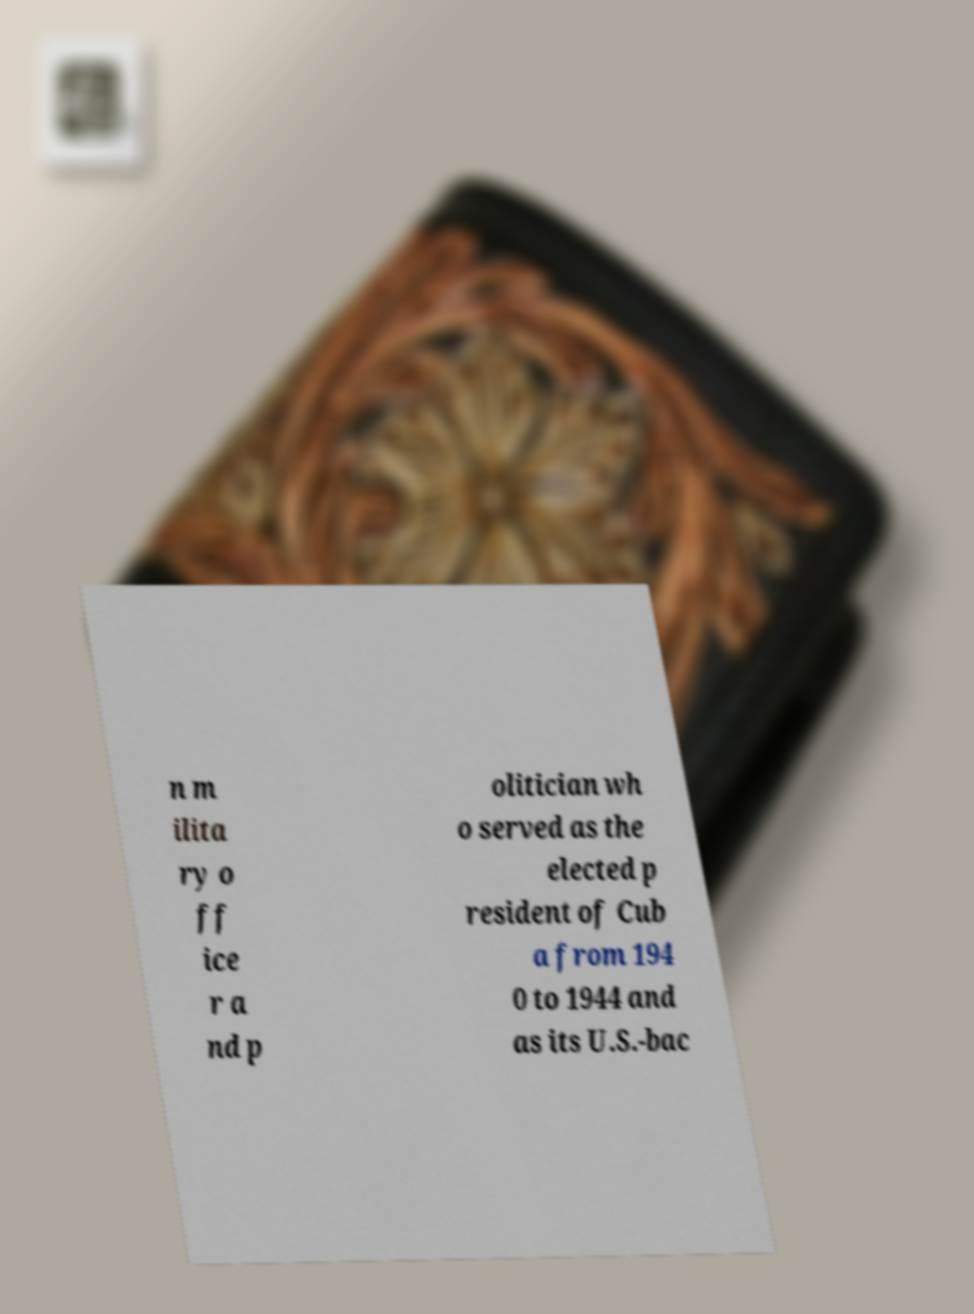Could you assist in decoding the text presented in this image and type it out clearly? n m ilita ry o ff ice r a nd p olitician wh o served as the elected p resident of Cub a from 194 0 to 1944 and as its U.S.-bac 